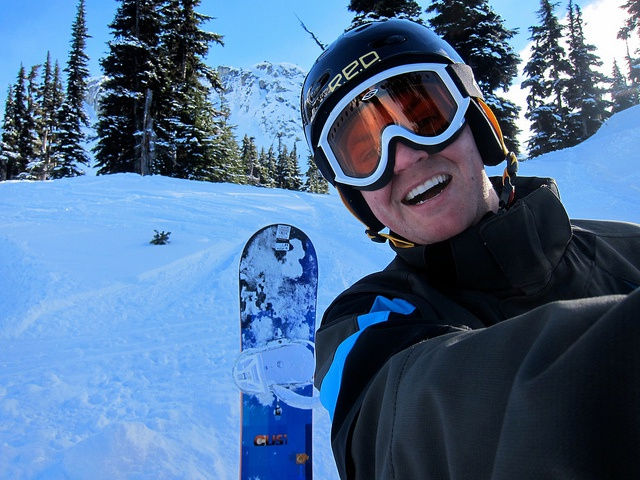Describe the objects in this image and their specific colors. I can see people in lightblue, black, navy, and gray tones and snowboard in lightblue, darkblue, blue, and navy tones in this image. 